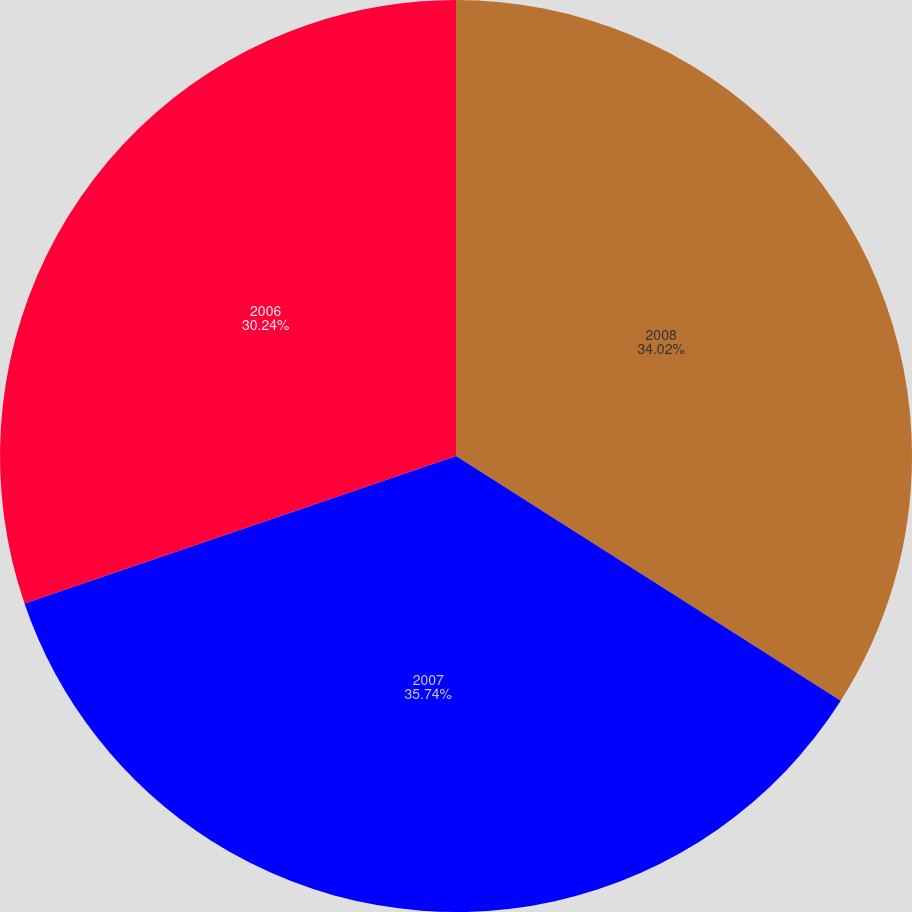Convert chart. <chart><loc_0><loc_0><loc_500><loc_500><pie_chart><fcel>2008<fcel>2007<fcel>2006<nl><fcel>34.02%<fcel>35.74%<fcel>30.24%<nl></chart> 